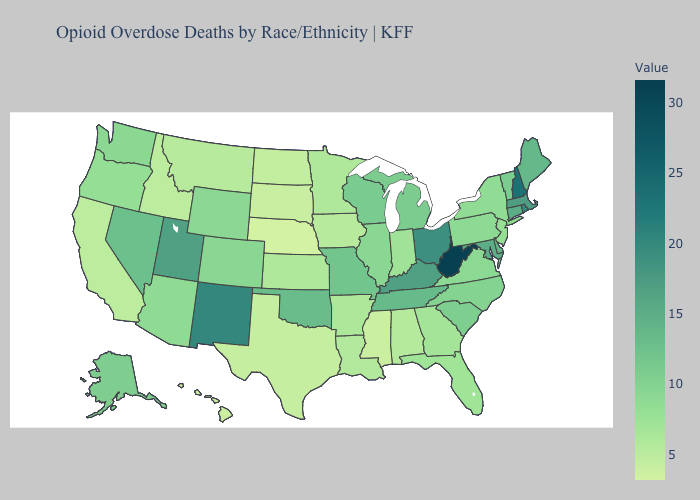Does New Jersey have the lowest value in the Northeast?
Short answer required. Yes. Among the states that border Connecticut , does New York have the lowest value?
Short answer required. Yes. Which states have the highest value in the USA?
Short answer required. West Virginia. Which states have the lowest value in the West?
Concise answer only. Hawaii. 